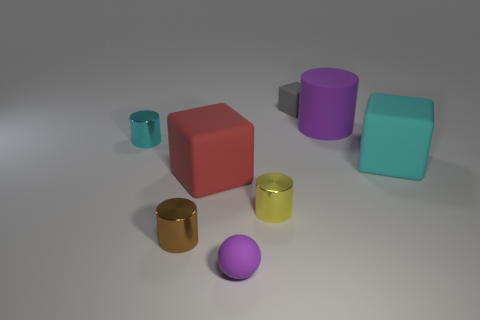Subtract all large cubes. How many cubes are left? 1 Add 1 cyan rubber blocks. How many objects exist? 9 Subtract all cyan cubes. How many cubes are left? 2 Subtract all blocks. How many objects are left? 5 Subtract 2 cylinders. How many cylinders are left? 2 Add 2 gray things. How many gray things are left? 3 Add 1 tiny brown cylinders. How many tiny brown cylinders exist? 2 Subtract 1 red cubes. How many objects are left? 7 Subtract all gray blocks. Subtract all brown cylinders. How many blocks are left? 2 Subtract all red blocks. How many cyan cylinders are left? 1 